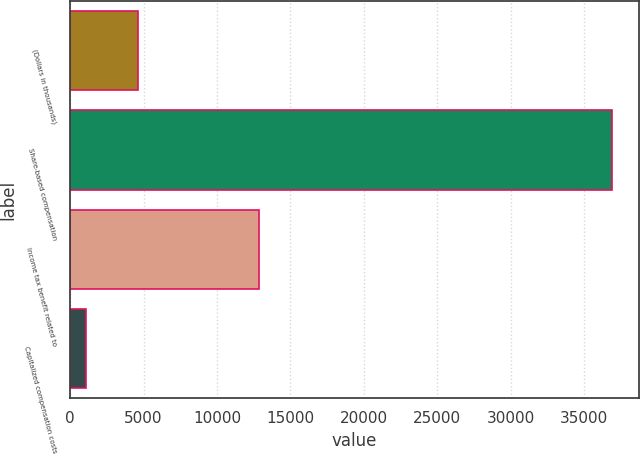Convert chart. <chart><loc_0><loc_0><loc_500><loc_500><bar_chart><fcel>(Dollars in thousands)<fcel>Share-based compensation<fcel>Income tax benefit related to<fcel>Capitalized compensation costs<nl><fcel>4653.9<fcel>36900<fcel>12845<fcel>1071<nl></chart> 